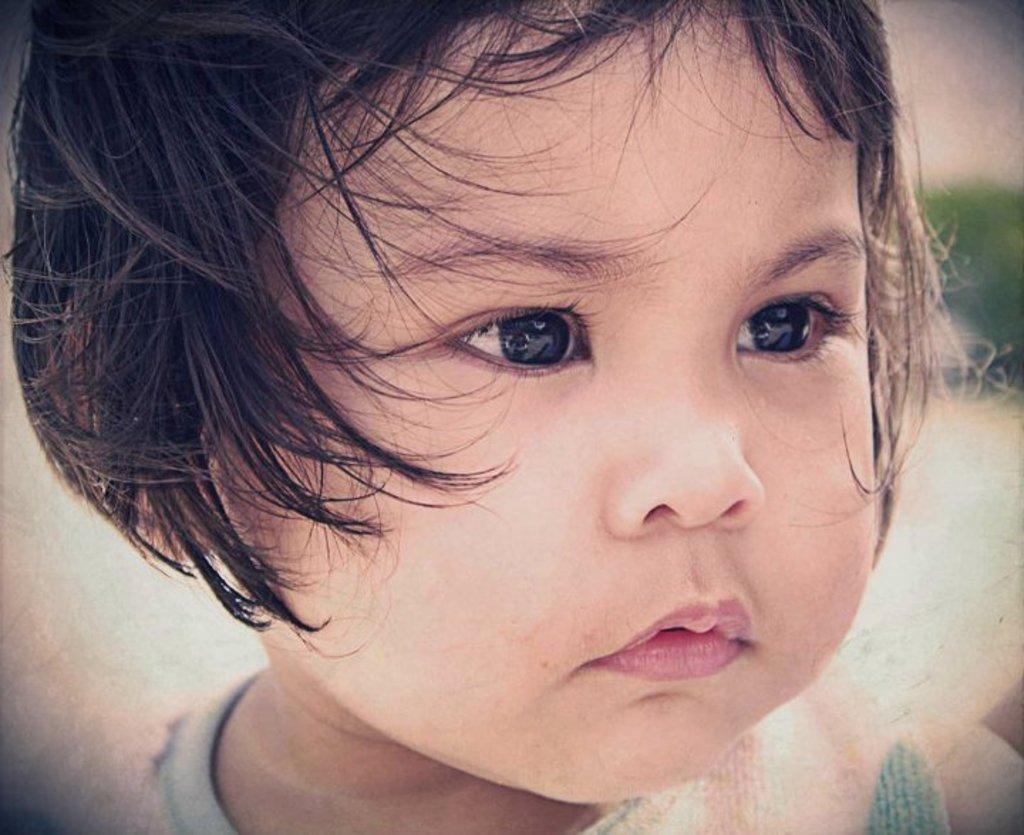Describe this image in one or two sentences. In this image I can see face of a baby in the front. On the right side of the image I can see a green colour thing and I can see this image is blurry in the background. 